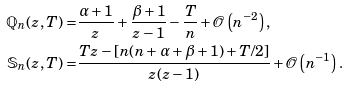<formula> <loc_0><loc_0><loc_500><loc_500>\mathbb { Q } _ { n } ( z , T ) = & \frac { \alpha + 1 } { z } + \frac { \beta + 1 } { z - 1 } - \frac { T } { n } + \mathcal { O } \left ( n ^ { - 2 } \right ) , \\ \mathbb { S } _ { n } ( z , T ) = & \frac { T z - [ n ( n + \alpha + \beta + 1 ) + T / 2 ] } { z ( z - 1 ) } + \mathcal { O } \left ( n ^ { - 1 } \right ) .</formula> 